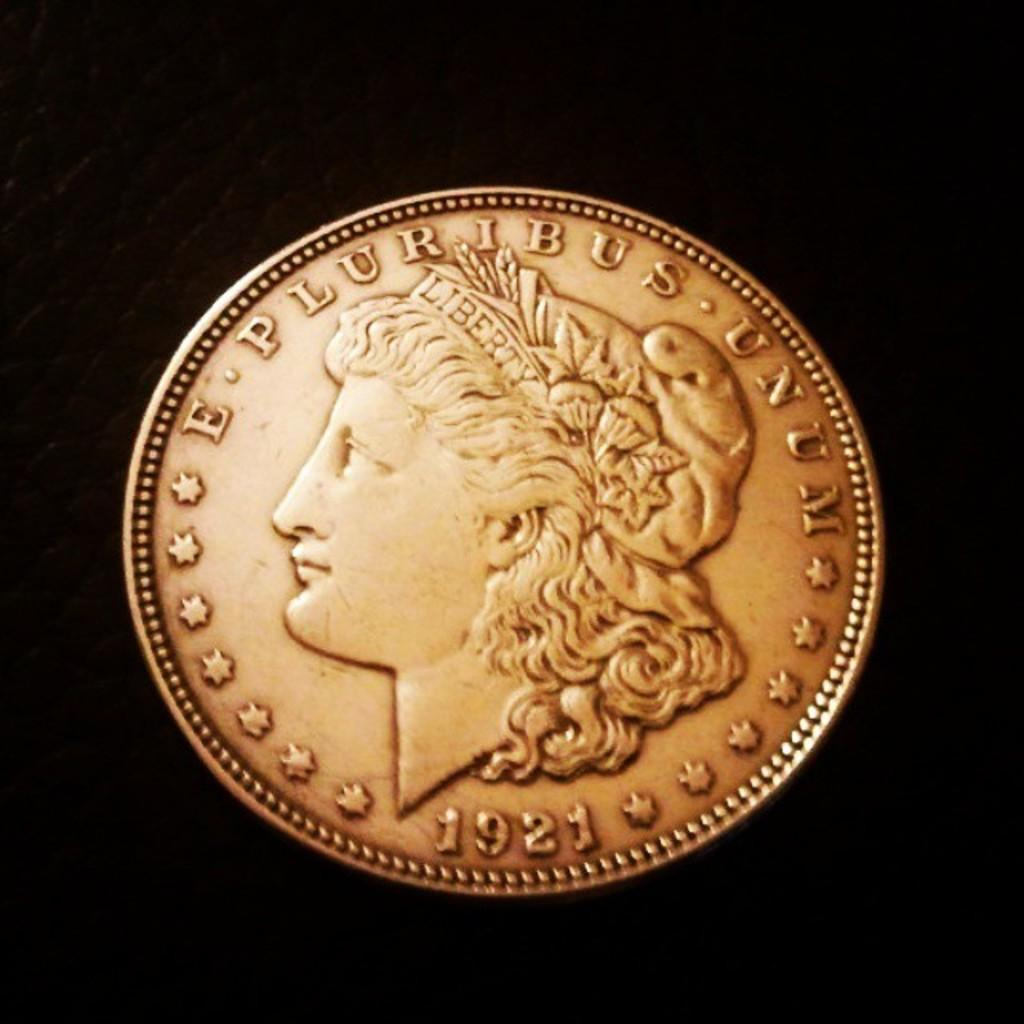<image>
Write a terse but informative summary of the picture. A 1921 Liberty coin has a dull shine to the gold. 